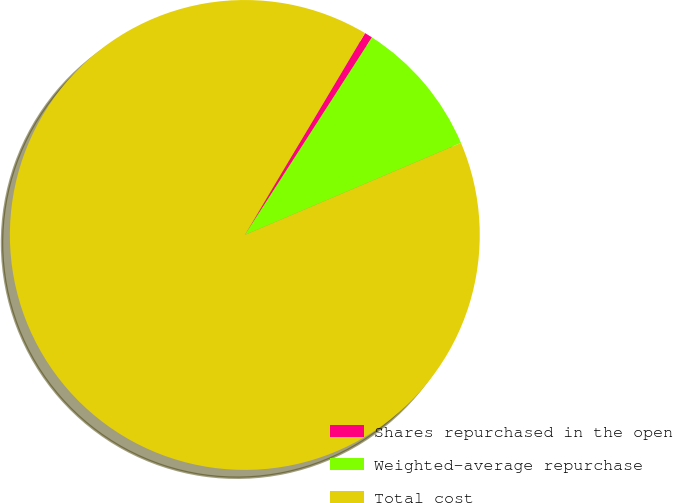<chart> <loc_0><loc_0><loc_500><loc_500><pie_chart><fcel>Shares repurchased in the open<fcel>Weighted-average repurchase<fcel>Total cost<nl><fcel>0.55%<fcel>9.49%<fcel>89.95%<nl></chart> 